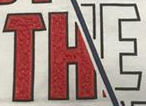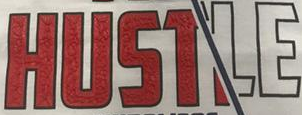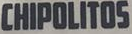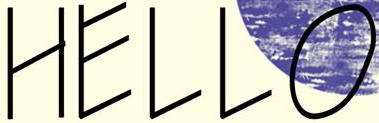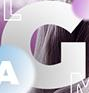What text is displayed in these images sequentially, separated by a semicolon? THE; HUSTLE; CHIPOLITOS; HELLO; G 